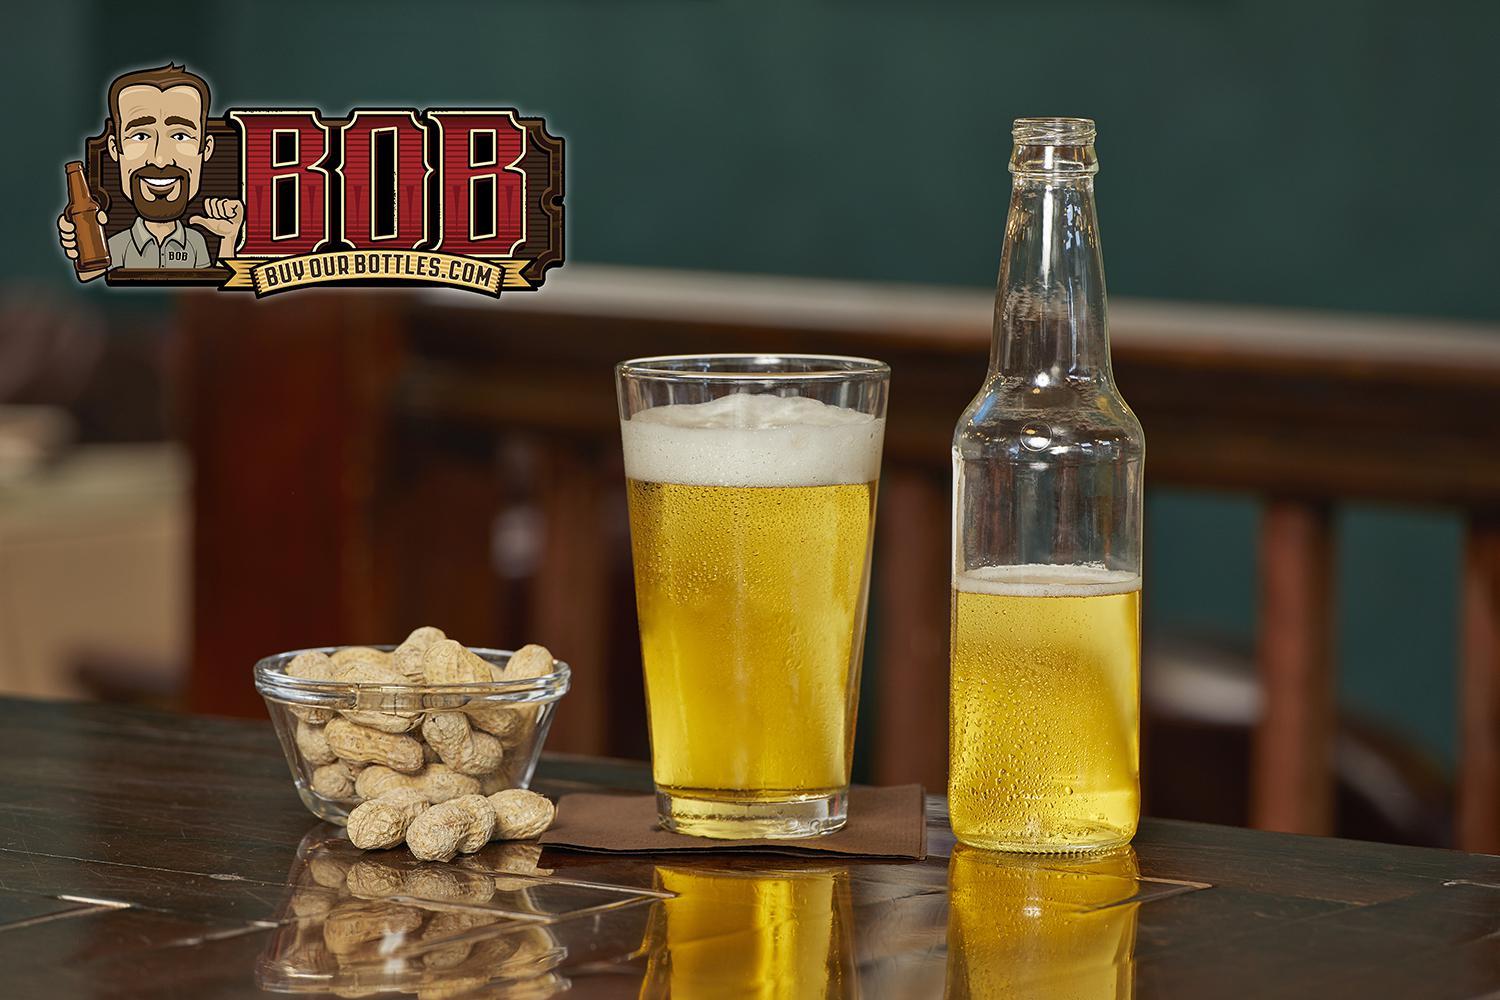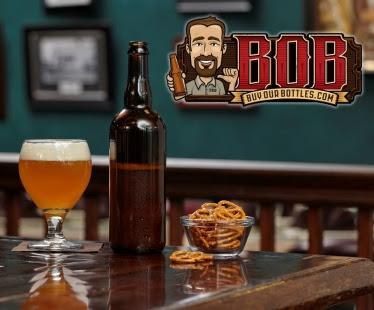The first image is the image on the left, the second image is the image on the right. Assess this claim about the two images: "The left image contains at least three times as many bottles as the right image, and the bottles in the right image are displayed on a visible flat surface.". Correct or not? Answer yes or no. No. The first image is the image on the left, the second image is the image on the right. Analyze the images presented: Is the assertion "In at least one image there are four rows of beer." valid? Answer yes or no. No. 